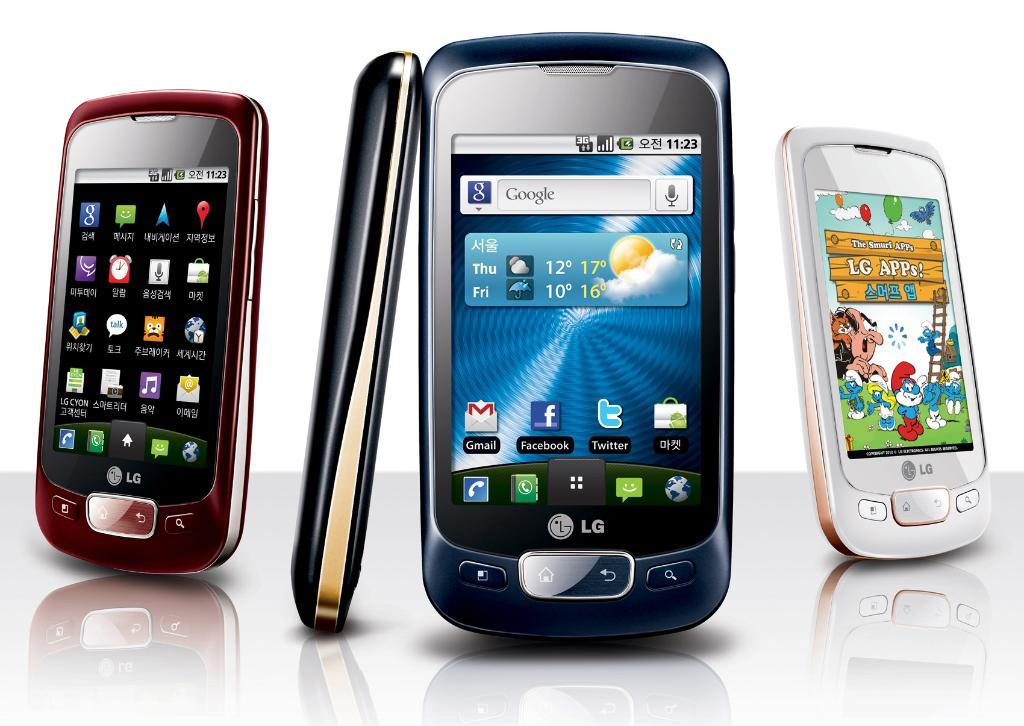<image>
Give a short and clear explanation of the subsequent image. Three different colors of an LG phone are displayed. 